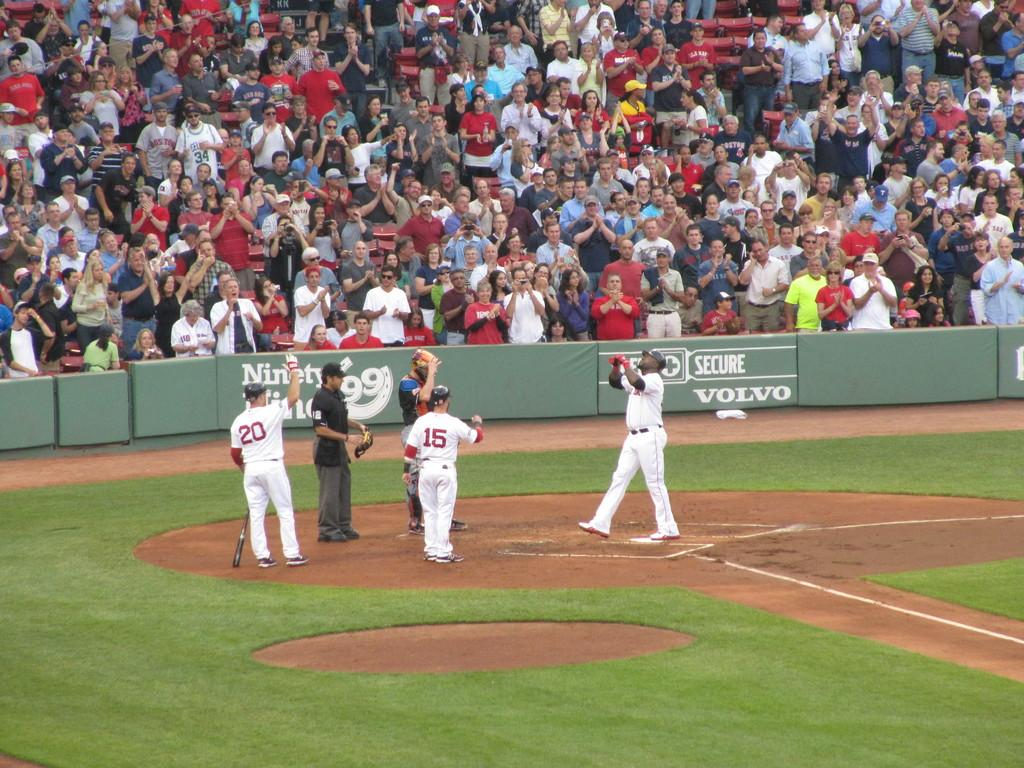<image>
Share a concise interpretation of the image provided. a baseball game is going on a a field that is sponsored by Volvo 